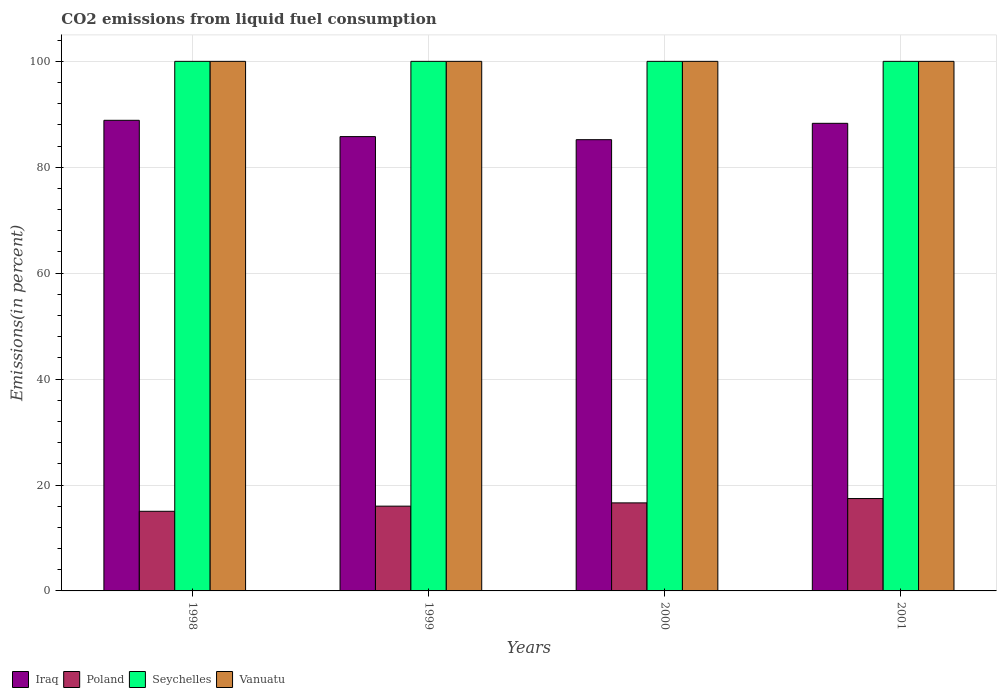How many groups of bars are there?
Your answer should be very brief. 4. Are the number of bars on each tick of the X-axis equal?
Make the answer very short. Yes. How many bars are there on the 4th tick from the left?
Provide a succinct answer. 4. How many bars are there on the 3rd tick from the right?
Keep it short and to the point. 4. What is the total CO2 emitted in Vanuatu in 2000?
Your answer should be very brief. 100. Across all years, what is the maximum total CO2 emitted in Poland?
Your answer should be very brief. 17.44. Across all years, what is the minimum total CO2 emitted in Vanuatu?
Ensure brevity in your answer.  100. In which year was the total CO2 emitted in Iraq maximum?
Give a very brief answer. 1998. In which year was the total CO2 emitted in Iraq minimum?
Keep it short and to the point. 2000. What is the total total CO2 emitted in Seychelles in the graph?
Offer a very short reply. 400. What is the difference between the total CO2 emitted in Poland in 1998 and that in 2000?
Keep it short and to the point. -1.59. What is the difference between the total CO2 emitted in Seychelles in 2000 and the total CO2 emitted in Iraq in 2001?
Ensure brevity in your answer.  11.7. In the year 1999, what is the difference between the total CO2 emitted in Iraq and total CO2 emitted in Seychelles?
Make the answer very short. -14.21. What is the difference between the highest and the second highest total CO2 emitted in Poland?
Offer a very short reply. 0.81. What is the difference between the highest and the lowest total CO2 emitted in Poland?
Provide a short and direct response. 2.4. In how many years, is the total CO2 emitted in Seychelles greater than the average total CO2 emitted in Seychelles taken over all years?
Provide a short and direct response. 0. Is the sum of the total CO2 emitted in Poland in 1998 and 1999 greater than the maximum total CO2 emitted in Seychelles across all years?
Provide a succinct answer. No. Is it the case that in every year, the sum of the total CO2 emitted in Iraq and total CO2 emitted in Poland is greater than the sum of total CO2 emitted in Seychelles and total CO2 emitted in Vanuatu?
Ensure brevity in your answer.  No. What does the 1st bar from the left in 2001 represents?
Keep it short and to the point. Iraq. What does the 4th bar from the right in 1999 represents?
Offer a terse response. Iraq. How many bars are there?
Your response must be concise. 16. How many years are there in the graph?
Ensure brevity in your answer.  4. Does the graph contain grids?
Ensure brevity in your answer.  Yes. Where does the legend appear in the graph?
Keep it short and to the point. Bottom left. How many legend labels are there?
Keep it short and to the point. 4. What is the title of the graph?
Provide a succinct answer. CO2 emissions from liquid fuel consumption. What is the label or title of the X-axis?
Your answer should be very brief. Years. What is the label or title of the Y-axis?
Keep it short and to the point. Emissions(in percent). What is the Emissions(in percent) in Iraq in 1998?
Provide a succinct answer. 88.87. What is the Emissions(in percent) in Poland in 1998?
Keep it short and to the point. 15.04. What is the Emissions(in percent) in Seychelles in 1998?
Make the answer very short. 100. What is the Emissions(in percent) of Iraq in 1999?
Offer a very short reply. 85.79. What is the Emissions(in percent) in Poland in 1999?
Your response must be concise. 16.01. What is the Emissions(in percent) of Vanuatu in 1999?
Make the answer very short. 100. What is the Emissions(in percent) in Iraq in 2000?
Make the answer very short. 85.21. What is the Emissions(in percent) in Poland in 2000?
Your response must be concise. 16.63. What is the Emissions(in percent) in Seychelles in 2000?
Your response must be concise. 100. What is the Emissions(in percent) in Iraq in 2001?
Keep it short and to the point. 88.3. What is the Emissions(in percent) of Poland in 2001?
Your answer should be compact. 17.44. What is the Emissions(in percent) in Seychelles in 2001?
Ensure brevity in your answer.  100. Across all years, what is the maximum Emissions(in percent) of Iraq?
Give a very brief answer. 88.87. Across all years, what is the maximum Emissions(in percent) of Poland?
Make the answer very short. 17.44. Across all years, what is the maximum Emissions(in percent) in Seychelles?
Your response must be concise. 100. Across all years, what is the maximum Emissions(in percent) in Vanuatu?
Provide a succinct answer. 100. Across all years, what is the minimum Emissions(in percent) in Iraq?
Make the answer very short. 85.21. Across all years, what is the minimum Emissions(in percent) in Poland?
Your answer should be very brief. 15.04. What is the total Emissions(in percent) of Iraq in the graph?
Ensure brevity in your answer.  348.17. What is the total Emissions(in percent) of Poland in the graph?
Provide a succinct answer. 65.11. What is the total Emissions(in percent) in Seychelles in the graph?
Offer a terse response. 400. What is the difference between the Emissions(in percent) of Iraq in 1998 and that in 1999?
Offer a very short reply. 3.08. What is the difference between the Emissions(in percent) of Poland in 1998 and that in 1999?
Your response must be concise. -0.97. What is the difference between the Emissions(in percent) of Seychelles in 1998 and that in 1999?
Offer a terse response. 0. What is the difference between the Emissions(in percent) of Iraq in 1998 and that in 2000?
Offer a very short reply. 3.66. What is the difference between the Emissions(in percent) of Poland in 1998 and that in 2000?
Keep it short and to the point. -1.59. What is the difference between the Emissions(in percent) in Iraq in 1998 and that in 2001?
Keep it short and to the point. 0.57. What is the difference between the Emissions(in percent) of Poland in 1998 and that in 2001?
Ensure brevity in your answer.  -2.4. What is the difference between the Emissions(in percent) of Vanuatu in 1998 and that in 2001?
Offer a terse response. 0. What is the difference between the Emissions(in percent) of Iraq in 1999 and that in 2000?
Your answer should be compact. 0.58. What is the difference between the Emissions(in percent) of Poland in 1999 and that in 2000?
Give a very brief answer. -0.62. What is the difference between the Emissions(in percent) of Seychelles in 1999 and that in 2000?
Offer a terse response. 0. What is the difference between the Emissions(in percent) of Iraq in 1999 and that in 2001?
Provide a short and direct response. -2.51. What is the difference between the Emissions(in percent) in Poland in 1999 and that in 2001?
Keep it short and to the point. -1.43. What is the difference between the Emissions(in percent) in Seychelles in 1999 and that in 2001?
Your answer should be compact. 0. What is the difference between the Emissions(in percent) in Vanuatu in 1999 and that in 2001?
Your answer should be compact. 0. What is the difference between the Emissions(in percent) of Iraq in 2000 and that in 2001?
Your response must be concise. -3.09. What is the difference between the Emissions(in percent) of Poland in 2000 and that in 2001?
Give a very brief answer. -0.81. What is the difference between the Emissions(in percent) of Iraq in 1998 and the Emissions(in percent) of Poland in 1999?
Offer a very short reply. 72.86. What is the difference between the Emissions(in percent) in Iraq in 1998 and the Emissions(in percent) in Seychelles in 1999?
Your answer should be compact. -11.13. What is the difference between the Emissions(in percent) in Iraq in 1998 and the Emissions(in percent) in Vanuatu in 1999?
Ensure brevity in your answer.  -11.13. What is the difference between the Emissions(in percent) of Poland in 1998 and the Emissions(in percent) of Seychelles in 1999?
Ensure brevity in your answer.  -84.96. What is the difference between the Emissions(in percent) of Poland in 1998 and the Emissions(in percent) of Vanuatu in 1999?
Your answer should be compact. -84.96. What is the difference between the Emissions(in percent) in Iraq in 1998 and the Emissions(in percent) in Poland in 2000?
Provide a succinct answer. 72.24. What is the difference between the Emissions(in percent) in Iraq in 1998 and the Emissions(in percent) in Seychelles in 2000?
Give a very brief answer. -11.13. What is the difference between the Emissions(in percent) in Iraq in 1998 and the Emissions(in percent) in Vanuatu in 2000?
Your answer should be very brief. -11.13. What is the difference between the Emissions(in percent) of Poland in 1998 and the Emissions(in percent) of Seychelles in 2000?
Provide a succinct answer. -84.96. What is the difference between the Emissions(in percent) in Poland in 1998 and the Emissions(in percent) in Vanuatu in 2000?
Your answer should be very brief. -84.96. What is the difference between the Emissions(in percent) in Seychelles in 1998 and the Emissions(in percent) in Vanuatu in 2000?
Provide a succinct answer. 0. What is the difference between the Emissions(in percent) of Iraq in 1998 and the Emissions(in percent) of Poland in 2001?
Your answer should be compact. 71.43. What is the difference between the Emissions(in percent) in Iraq in 1998 and the Emissions(in percent) in Seychelles in 2001?
Keep it short and to the point. -11.13. What is the difference between the Emissions(in percent) in Iraq in 1998 and the Emissions(in percent) in Vanuatu in 2001?
Give a very brief answer. -11.13. What is the difference between the Emissions(in percent) of Poland in 1998 and the Emissions(in percent) of Seychelles in 2001?
Ensure brevity in your answer.  -84.96. What is the difference between the Emissions(in percent) in Poland in 1998 and the Emissions(in percent) in Vanuatu in 2001?
Give a very brief answer. -84.96. What is the difference between the Emissions(in percent) of Iraq in 1999 and the Emissions(in percent) of Poland in 2000?
Offer a terse response. 69.16. What is the difference between the Emissions(in percent) of Iraq in 1999 and the Emissions(in percent) of Seychelles in 2000?
Your response must be concise. -14.21. What is the difference between the Emissions(in percent) in Iraq in 1999 and the Emissions(in percent) in Vanuatu in 2000?
Your response must be concise. -14.21. What is the difference between the Emissions(in percent) in Poland in 1999 and the Emissions(in percent) in Seychelles in 2000?
Offer a terse response. -83.99. What is the difference between the Emissions(in percent) in Poland in 1999 and the Emissions(in percent) in Vanuatu in 2000?
Your response must be concise. -83.99. What is the difference between the Emissions(in percent) in Iraq in 1999 and the Emissions(in percent) in Poland in 2001?
Ensure brevity in your answer.  68.35. What is the difference between the Emissions(in percent) of Iraq in 1999 and the Emissions(in percent) of Seychelles in 2001?
Make the answer very short. -14.21. What is the difference between the Emissions(in percent) of Iraq in 1999 and the Emissions(in percent) of Vanuatu in 2001?
Your answer should be very brief. -14.21. What is the difference between the Emissions(in percent) in Poland in 1999 and the Emissions(in percent) in Seychelles in 2001?
Your response must be concise. -83.99. What is the difference between the Emissions(in percent) in Poland in 1999 and the Emissions(in percent) in Vanuatu in 2001?
Offer a terse response. -83.99. What is the difference between the Emissions(in percent) in Seychelles in 1999 and the Emissions(in percent) in Vanuatu in 2001?
Your answer should be compact. 0. What is the difference between the Emissions(in percent) of Iraq in 2000 and the Emissions(in percent) of Poland in 2001?
Your answer should be very brief. 67.77. What is the difference between the Emissions(in percent) of Iraq in 2000 and the Emissions(in percent) of Seychelles in 2001?
Your answer should be very brief. -14.79. What is the difference between the Emissions(in percent) in Iraq in 2000 and the Emissions(in percent) in Vanuatu in 2001?
Offer a very short reply. -14.79. What is the difference between the Emissions(in percent) of Poland in 2000 and the Emissions(in percent) of Seychelles in 2001?
Your answer should be compact. -83.37. What is the difference between the Emissions(in percent) in Poland in 2000 and the Emissions(in percent) in Vanuatu in 2001?
Keep it short and to the point. -83.37. What is the difference between the Emissions(in percent) of Seychelles in 2000 and the Emissions(in percent) of Vanuatu in 2001?
Your response must be concise. 0. What is the average Emissions(in percent) of Iraq per year?
Give a very brief answer. 87.04. What is the average Emissions(in percent) of Poland per year?
Provide a short and direct response. 16.28. What is the average Emissions(in percent) in Vanuatu per year?
Your response must be concise. 100. In the year 1998, what is the difference between the Emissions(in percent) of Iraq and Emissions(in percent) of Poland?
Provide a short and direct response. 73.83. In the year 1998, what is the difference between the Emissions(in percent) in Iraq and Emissions(in percent) in Seychelles?
Provide a succinct answer. -11.13. In the year 1998, what is the difference between the Emissions(in percent) in Iraq and Emissions(in percent) in Vanuatu?
Give a very brief answer. -11.13. In the year 1998, what is the difference between the Emissions(in percent) of Poland and Emissions(in percent) of Seychelles?
Ensure brevity in your answer.  -84.96. In the year 1998, what is the difference between the Emissions(in percent) in Poland and Emissions(in percent) in Vanuatu?
Offer a very short reply. -84.96. In the year 1998, what is the difference between the Emissions(in percent) of Seychelles and Emissions(in percent) of Vanuatu?
Your answer should be compact. 0. In the year 1999, what is the difference between the Emissions(in percent) of Iraq and Emissions(in percent) of Poland?
Keep it short and to the point. 69.78. In the year 1999, what is the difference between the Emissions(in percent) in Iraq and Emissions(in percent) in Seychelles?
Keep it short and to the point. -14.21. In the year 1999, what is the difference between the Emissions(in percent) of Iraq and Emissions(in percent) of Vanuatu?
Your answer should be compact. -14.21. In the year 1999, what is the difference between the Emissions(in percent) of Poland and Emissions(in percent) of Seychelles?
Make the answer very short. -83.99. In the year 1999, what is the difference between the Emissions(in percent) of Poland and Emissions(in percent) of Vanuatu?
Ensure brevity in your answer.  -83.99. In the year 1999, what is the difference between the Emissions(in percent) in Seychelles and Emissions(in percent) in Vanuatu?
Make the answer very short. 0. In the year 2000, what is the difference between the Emissions(in percent) of Iraq and Emissions(in percent) of Poland?
Your answer should be compact. 68.58. In the year 2000, what is the difference between the Emissions(in percent) of Iraq and Emissions(in percent) of Seychelles?
Ensure brevity in your answer.  -14.79. In the year 2000, what is the difference between the Emissions(in percent) in Iraq and Emissions(in percent) in Vanuatu?
Offer a terse response. -14.79. In the year 2000, what is the difference between the Emissions(in percent) in Poland and Emissions(in percent) in Seychelles?
Offer a very short reply. -83.37. In the year 2000, what is the difference between the Emissions(in percent) in Poland and Emissions(in percent) in Vanuatu?
Your answer should be compact. -83.37. In the year 2001, what is the difference between the Emissions(in percent) of Iraq and Emissions(in percent) of Poland?
Provide a short and direct response. 70.86. In the year 2001, what is the difference between the Emissions(in percent) in Iraq and Emissions(in percent) in Seychelles?
Give a very brief answer. -11.7. In the year 2001, what is the difference between the Emissions(in percent) of Iraq and Emissions(in percent) of Vanuatu?
Offer a terse response. -11.7. In the year 2001, what is the difference between the Emissions(in percent) in Poland and Emissions(in percent) in Seychelles?
Make the answer very short. -82.56. In the year 2001, what is the difference between the Emissions(in percent) of Poland and Emissions(in percent) of Vanuatu?
Keep it short and to the point. -82.56. What is the ratio of the Emissions(in percent) of Iraq in 1998 to that in 1999?
Provide a succinct answer. 1.04. What is the ratio of the Emissions(in percent) in Poland in 1998 to that in 1999?
Make the answer very short. 0.94. What is the ratio of the Emissions(in percent) in Seychelles in 1998 to that in 1999?
Your response must be concise. 1. What is the ratio of the Emissions(in percent) in Iraq in 1998 to that in 2000?
Keep it short and to the point. 1.04. What is the ratio of the Emissions(in percent) in Poland in 1998 to that in 2000?
Make the answer very short. 0.9. What is the ratio of the Emissions(in percent) of Vanuatu in 1998 to that in 2000?
Your answer should be compact. 1. What is the ratio of the Emissions(in percent) of Iraq in 1998 to that in 2001?
Ensure brevity in your answer.  1.01. What is the ratio of the Emissions(in percent) in Poland in 1998 to that in 2001?
Offer a terse response. 0.86. What is the ratio of the Emissions(in percent) of Seychelles in 1998 to that in 2001?
Provide a succinct answer. 1. What is the ratio of the Emissions(in percent) of Iraq in 1999 to that in 2000?
Keep it short and to the point. 1.01. What is the ratio of the Emissions(in percent) of Poland in 1999 to that in 2000?
Your answer should be very brief. 0.96. What is the ratio of the Emissions(in percent) of Iraq in 1999 to that in 2001?
Provide a short and direct response. 0.97. What is the ratio of the Emissions(in percent) in Poland in 1999 to that in 2001?
Your response must be concise. 0.92. What is the ratio of the Emissions(in percent) of Seychelles in 1999 to that in 2001?
Make the answer very short. 1. What is the ratio of the Emissions(in percent) in Iraq in 2000 to that in 2001?
Your answer should be compact. 0.96. What is the ratio of the Emissions(in percent) of Poland in 2000 to that in 2001?
Keep it short and to the point. 0.95. What is the difference between the highest and the second highest Emissions(in percent) of Iraq?
Provide a short and direct response. 0.57. What is the difference between the highest and the second highest Emissions(in percent) in Poland?
Offer a very short reply. 0.81. What is the difference between the highest and the second highest Emissions(in percent) in Seychelles?
Provide a succinct answer. 0. What is the difference between the highest and the lowest Emissions(in percent) in Iraq?
Offer a terse response. 3.66. What is the difference between the highest and the lowest Emissions(in percent) in Poland?
Provide a short and direct response. 2.4. What is the difference between the highest and the lowest Emissions(in percent) in Seychelles?
Provide a succinct answer. 0. What is the difference between the highest and the lowest Emissions(in percent) of Vanuatu?
Your answer should be very brief. 0. 